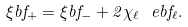Convert formula to latex. <formula><loc_0><loc_0><loc_500><loc_500>\xi b f _ { + } = \xi b f _ { - } + 2 \chi _ { \ell } \ e b f _ { \ell } .</formula> 